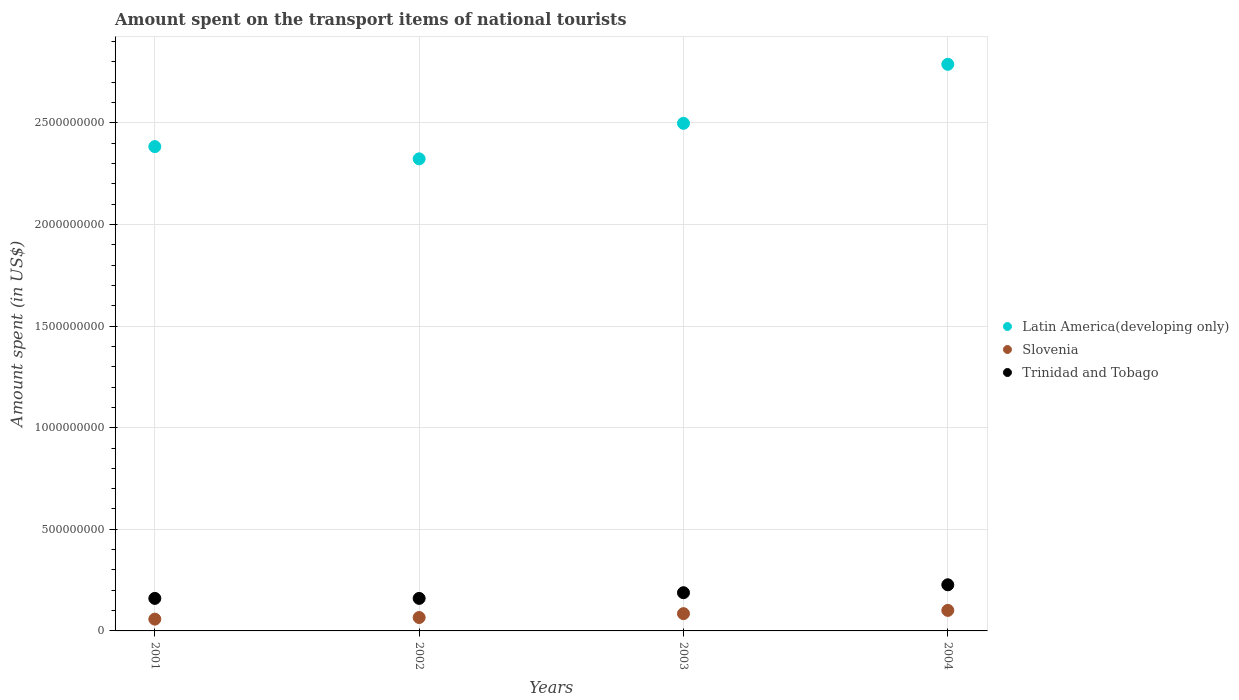Is the number of dotlines equal to the number of legend labels?
Offer a terse response. Yes. What is the amount spent on the transport items of national tourists in Trinidad and Tobago in 2003?
Your answer should be compact. 1.88e+08. Across all years, what is the maximum amount spent on the transport items of national tourists in Latin America(developing only)?
Your response must be concise. 2.79e+09. Across all years, what is the minimum amount spent on the transport items of national tourists in Trinidad and Tobago?
Offer a very short reply. 1.60e+08. In which year was the amount spent on the transport items of national tourists in Trinidad and Tobago minimum?
Provide a short and direct response. 2001. What is the total amount spent on the transport items of national tourists in Trinidad and Tobago in the graph?
Make the answer very short. 7.35e+08. What is the difference between the amount spent on the transport items of national tourists in Slovenia in 2001 and that in 2004?
Give a very brief answer. -4.30e+07. What is the difference between the amount spent on the transport items of national tourists in Slovenia in 2003 and the amount spent on the transport items of national tourists in Trinidad and Tobago in 2001?
Ensure brevity in your answer.  -7.50e+07. What is the average amount spent on the transport items of national tourists in Slovenia per year?
Provide a succinct answer. 7.75e+07. In the year 2001, what is the difference between the amount spent on the transport items of national tourists in Trinidad and Tobago and amount spent on the transport items of national tourists in Slovenia?
Your answer should be very brief. 1.02e+08. In how many years, is the amount spent on the transport items of national tourists in Latin America(developing only) greater than 100000000 US$?
Make the answer very short. 4. What is the ratio of the amount spent on the transport items of national tourists in Latin America(developing only) in 2003 to that in 2004?
Give a very brief answer. 0.9. Is the amount spent on the transport items of national tourists in Trinidad and Tobago in 2002 less than that in 2004?
Ensure brevity in your answer.  Yes. Is the difference between the amount spent on the transport items of national tourists in Trinidad and Tobago in 2002 and 2004 greater than the difference between the amount spent on the transport items of national tourists in Slovenia in 2002 and 2004?
Your answer should be compact. No. What is the difference between the highest and the second highest amount spent on the transport items of national tourists in Latin America(developing only)?
Provide a short and direct response. 2.90e+08. What is the difference between the highest and the lowest amount spent on the transport items of national tourists in Slovenia?
Provide a succinct answer. 4.30e+07. Is it the case that in every year, the sum of the amount spent on the transport items of national tourists in Latin America(developing only) and amount spent on the transport items of national tourists in Trinidad and Tobago  is greater than the amount spent on the transport items of national tourists in Slovenia?
Your response must be concise. Yes. Does the amount spent on the transport items of national tourists in Latin America(developing only) monotonically increase over the years?
Make the answer very short. No. Is the amount spent on the transport items of national tourists in Latin America(developing only) strictly greater than the amount spent on the transport items of national tourists in Slovenia over the years?
Provide a succinct answer. Yes. Is the amount spent on the transport items of national tourists in Trinidad and Tobago strictly less than the amount spent on the transport items of national tourists in Slovenia over the years?
Offer a very short reply. No. What is the difference between two consecutive major ticks on the Y-axis?
Give a very brief answer. 5.00e+08. Does the graph contain grids?
Offer a terse response. Yes. How are the legend labels stacked?
Give a very brief answer. Vertical. What is the title of the graph?
Give a very brief answer. Amount spent on the transport items of national tourists. What is the label or title of the X-axis?
Your response must be concise. Years. What is the label or title of the Y-axis?
Offer a very short reply. Amount spent (in US$). What is the Amount spent (in US$) of Latin America(developing only) in 2001?
Offer a very short reply. 2.38e+09. What is the Amount spent (in US$) of Slovenia in 2001?
Keep it short and to the point. 5.80e+07. What is the Amount spent (in US$) in Trinidad and Tobago in 2001?
Provide a short and direct response. 1.60e+08. What is the Amount spent (in US$) of Latin America(developing only) in 2002?
Give a very brief answer. 2.32e+09. What is the Amount spent (in US$) of Slovenia in 2002?
Provide a short and direct response. 6.60e+07. What is the Amount spent (in US$) in Trinidad and Tobago in 2002?
Provide a succinct answer. 1.60e+08. What is the Amount spent (in US$) in Latin America(developing only) in 2003?
Your response must be concise. 2.50e+09. What is the Amount spent (in US$) of Slovenia in 2003?
Provide a short and direct response. 8.50e+07. What is the Amount spent (in US$) of Trinidad and Tobago in 2003?
Make the answer very short. 1.88e+08. What is the Amount spent (in US$) of Latin America(developing only) in 2004?
Ensure brevity in your answer.  2.79e+09. What is the Amount spent (in US$) in Slovenia in 2004?
Offer a very short reply. 1.01e+08. What is the Amount spent (in US$) of Trinidad and Tobago in 2004?
Provide a succinct answer. 2.27e+08. Across all years, what is the maximum Amount spent (in US$) in Latin America(developing only)?
Give a very brief answer. 2.79e+09. Across all years, what is the maximum Amount spent (in US$) of Slovenia?
Your response must be concise. 1.01e+08. Across all years, what is the maximum Amount spent (in US$) in Trinidad and Tobago?
Keep it short and to the point. 2.27e+08. Across all years, what is the minimum Amount spent (in US$) in Latin America(developing only)?
Offer a terse response. 2.32e+09. Across all years, what is the minimum Amount spent (in US$) in Slovenia?
Provide a succinct answer. 5.80e+07. Across all years, what is the minimum Amount spent (in US$) in Trinidad and Tobago?
Provide a succinct answer. 1.60e+08. What is the total Amount spent (in US$) of Latin America(developing only) in the graph?
Offer a very short reply. 9.99e+09. What is the total Amount spent (in US$) in Slovenia in the graph?
Provide a succinct answer. 3.10e+08. What is the total Amount spent (in US$) in Trinidad and Tobago in the graph?
Your answer should be very brief. 7.35e+08. What is the difference between the Amount spent (in US$) in Latin America(developing only) in 2001 and that in 2002?
Provide a succinct answer. 6.03e+07. What is the difference between the Amount spent (in US$) in Slovenia in 2001 and that in 2002?
Offer a terse response. -8.00e+06. What is the difference between the Amount spent (in US$) of Latin America(developing only) in 2001 and that in 2003?
Provide a short and direct response. -1.14e+08. What is the difference between the Amount spent (in US$) in Slovenia in 2001 and that in 2003?
Your answer should be compact. -2.70e+07. What is the difference between the Amount spent (in US$) in Trinidad and Tobago in 2001 and that in 2003?
Provide a succinct answer. -2.80e+07. What is the difference between the Amount spent (in US$) in Latin America(developing only) in 2001 and that in 2004?
Your answer should be very brief. -4.05e+08. What is the difference between the Amount spent (in US$) in Slovenia in 2001 and that in 2004?
Provide a succinct answer. -4.30e+07. What is the difference between the Amount spent (in US$) of Trinidad and Tobago in 2001 and that in 2004?
Make the answer very short. -6.70e+07. What is the difference between the Amount spent (in US$) in Latin America(developing only) in 2002 and that in 2003?
Provide a succinct answer. -1.75e+08. What is the difference between the Amount spent (in US$) of Slovenia in 2002 and that in 2003?
Make the answer very short. -1.90e+07. What is the difference between the Amount spent (in US$) in Trinidad and Tobago in 2002 and that in 2003?
Provide a succinct answer. -2.80e+07. What is the difference between the Amount spent (in US$) in Latin America(developing only) in 2002 and that in 2004?
Your response must be concise. -4.65e+08. What is the difference between the Amount spent (in US$) of Slovenia in 2002 and that in 2004?
Give a very brief answer. -3.50e+07. What is the difference between the Amount spent (in US$) of Trinidad and Tobago in 2002 and that in 2004?
Provide a succinct answer. -6.70e+07. What is the difference between the Amount spent (in US$) in Latin America(developing only) in 2003 and that in 2004?
Offer a very short reply. -2.90e+08. What is the difference between the Amount spent (in US$) of Slovenia in 2003 and that in 2004?
Your answer should be compact. -1.60e+07. What is the difference between the Amount spent (in US$) in Trinidad and Tobago in 2003 and that in 2004?
Ensure brevity in your answer.  -3.90e+07. What is the difference between the Amount spent (in US$) in Latin America(developing only) in 2001 and the Amount spent (in US$) in Slovenia in 2002?
Ensure brevity in your answer.  2.32e+09. What is the difference between the Amount spent (in US$) of Latin America(developing only) in 2001 and the Amount spent (in US$) of Trinidad and Tobago in 2002?
Provide a succinct answer. 2.22e+09. What is the difference between the Amount spent (in US$) in Slovenia in 2001 and the Amount spent (in US$) in Trinidad and Tobago in 2002?
Give a very brief answer. -1.02e+08. What is the difference between the Amount spent (in US$) of Latin America(developing only) in 2001 and the Amount spent (in US$) of Slovenia in 2003?
Give a very brief answer. 2.30e+09. What is the difference between the Amount spent (in US$) of Latin America(developing only) in 2001 and the Amount spent (in US$) of Trinidad and Tobago in 2003?
Your response must be concise. 2.20e+09. What is the difference between the Amount spent (in US$) in Slovenia in 2001 and the Amount spent (in US$) in Trinidad and Tobago in 2003?
Your answer should be compact. -1.30e+08. What is the difference between the Amount spent (in US$) of Latin America(developing only) in 2001 and the Amount spent (in US$) of Slovenia in 2004?
Your answer should be very brief. 2.28e+09. What is the difference between the Amount spent (in US$) of Latin America(developing only) in 2001 and the Amount spent (in US$) of Trinidad and Tobago in 2004?
Provide a succinct answer. 2.16e+09. What is the difference between the Amount spent (in US$) of Slovenia in 2001 and the Amount spent (in US$) of Trinidad and Tobago in 2004?
Offer a very short reply. -1.69e+08. What is the difference between the Amount spent (in US$) in Latin America(developing only) in 2002 and the Amount spent (in US$) in Slovenia in 2003?
Make the answer very short. 2.24e+09. What is the difference between the Amount spent (in US$) of Latin America(developing only) in 2002 and the Amount spent (in US$) of Trinidad and Tobago in 2003?
Your answer should be compact. 2.13e+09. What is the difference between the Amount spent (in US$) of Slovenia in 2002 and the Amount spent (in US$) of Trinidad and Tobago in 2003?
Your response must be concise. -1.22e+08. What is the difference between the Amount spent (in US$) in Latin America(developing only) in 2002 and the Amount spent (in US$) in Slovenia in 2004?
Give a very brief answer. 2.22e+09. What is the difference between the Amount spent (in US$) of Latin America(developing only) in 2002 and the Amount spent (in US$) of Trinidad and Tobago in 2004?
Offer a terse response. 2.10e+09. What is the difference between the Amount spent (in US$) of Slovenia in 2002 and the Amount spent (in US$) of Trinidad and Tobago in 2004?
Offer a terse response. -1.61e+08. What is the difference between the Amount spent (in US$) of Latin America(developing only) in 2003 and the Amount spent (in US$) of Slovenia in 2004?
Offer a very short reply. 2.40e+09. What is the difference between the Amount spent (in US$) of Latin America(developing only) in 2003 and the Amount spent (in US$) of Trinidad and Tobago in 2004?
Keep it short and to the point. 2.27e+09. What is the difference between the Amount spent (in US$) of Slovenia in 2003 and the Amount spent (in US$) of Trinidad and Tobago in 2004?
Offer a very short reply. -1.42e+08. What is the average Amount spent (in US$) of Latin America(developing only) per year?
Give a very brief answer. 2.50e+09. What is the average Amount spent (in US$) of Slovenia per year?
Make the answer very short. 7.75e+07. What is the average Amount spent (in US$) in Trinidad and Tobago per year?
Provide a short and direct response. 1.84e+08. In the year 2001, what is the difference between the Amount spent (in US$) in Latin America(developing only) and Amount spent (in US$) in Slovenia?
Make the answer very short. 2.33e+09. In the year 2001, what is the difference between the Amount spent (in US$) of Latin America(developing only) and Amount spent (in US$) of Trinidad and Tobago?
Your answer should be very brief. 2.22e+09. In the year 2001, what is the difference between the Amount spent (in US$) in Slovenia and Amount spent (in US$) in Trinidad and Tobago?
Ensure brevity in your answer.  -1.02e+08. In the year 2002, what is the difference between the Amount spent (in US$) in Latin America(developing only) and Amount spent (in US$) in Slovenia?
Provide a short and direct response. 2.26e+09. In the year 2002, what is the difference between the Amount spent (in US$) in Latin America(developing only) and Amount spent (in US$) in Trinidad and Tobago?
Your answer should be compact. 2.16e+09. In the year 2002, what is the difference between the Amount spent (in US$) in Slovenia and Amount spent (in US$) in Trinidad and Tobago?
Provide a short and direct response. -9.40e+07. In the year 2003, what is the difference between the Amount spent (in US$) in Latin America(developing only) and Amount spent (in US$) in Slovenia?
Give a very brief answer. 2.41e+09. In the year 2003, what is the difference between the Amount spent (in US$) in Latin America(developing only) and Amount spent (in US$) in Trinidad and Tobago?
Your answer should be very brief. 2.31e+09. In the year 2003, what is the difference between the Amount spent (in US$) in Slovenia and Amount spent (in US$) in Trinidad and Tobago?
Keep it short and to the point. -1.03e+08. In the year 2004, what is the difference between the Amount spent (in US$) in Latin America(developing only) and Amount spent (in US$) in Slovenia?
Offer a terse response. 2.69e+09. In the year 2004, what is the difference between the Amount spent (in US$) in Latin America(developing only) and Amount spent (in US$) in Trinidad and Tobago?
Provide a short and direct response. 2.56e+09. In the year 2004, what is the difference between the Amount spent (in US$) of Slovenia and Amount spent (in US$) of Trinidad and Tobago?
Offer a very short reply. -1.26e+08. What is the ratio of the Amount spent (in US$) in Slovenia in 2001 to that in 2002?
Your answer should be very brief. 0.88. What is the ratio of the Amount spent (in US$) of Trinidad and Tobago in 2001 to that in 2002?
Offer a very short reply. 1. What is the ratio of the Amount spent (in US$) of Latin America(developing only) in 2001 to that in 2003?
Give a very brief answer. 0.95. What is the ratio of the Amount spent (in US$) in Slovenia in 2001 to that in 2003?
Make the answer very short. 0.68. What is the ratio of the Amount spent (in US$) in Trinidad and Tobago in 2001 to that in 2003?
Your answer should be very brief. 0.85. What is the ratio of the Amount spent (in US$) in Latin America(developing only) in 2001 to that in 2004?
Make the answer very short. 0.85. What is the ratio of the Amount spent (in US$) of Slovenia in 2001 to that in 2004?
Give a very brief answer. 0.57. What is the ratio of the Amount spent (in US$) in Trinidad and Tobago in 2001 to that in 2004?
Give a very brief answer. 0.7. What is the ratio of the Amount spent (in US$) of Latin America(developing only) in 2002 to that in 2003?
Provide a short and direct response. 0.93. What is the ratio of the Amount spent (in US$) in Slovenia in 2002 to that in 2003?
Provide a short and direct response. 0.78. What is the ratio of the Amount spent (in US$) of Trinidad and Tobago in 2002 to that in 2003?
Give a very brief answer. 0.85. What is the ratio of the Amount spent (in US$) of Latin America(developing only) in 2002 to that in 2004?
Your response must be concise. 0.83. What is the ratio of the Amount spent (in US$) in Slovenia in 2002 to that in 2004?
Offer a terse response. 0.65. What is the ratio of the Amount spent (in US$) in Trinidad and Tobago in 2002 to that in 2004?
Make the answer very short. 0.7. What is the ratio of the Amount spent (in US$) of Latin America(developing only) in 2003 to that in 2004?
Provide a succinct answer. 0.9. What is the ratio of the Amount spent (in US$) of Slovenia in 2003 to that in 2004?
Provide a succinct answer. 0.84. What is the ratio of the Amount spent (in US$) of Trinidad and Tobago in 2003 to that in 2004?
Keep it short and to the point. 0.83. What is the difference between the highest and the second highest Amount spent (in US$) of Latin America(developing only)?
Your answer should be very brief. 2.90e+08. What is the difference between the highest and the second highest Amount spent (in US$) in Slovenia?
Give a very brief answer. 1.60e+07. What is the difference between the highest and the second highest Amount spent (in US$) of Trinidad and Tobago?
Provide a succinct answer. 3.90e+07. What is the difference between the highest and the lowest Amount spent (in US$) in Latin America(developing only)?
Offer a very short reply. 4.65e+08. What is the difference between the highest and the lowest Amount spent (in US$) of Slovenia?
Give a very brief answer. 4.30e+07. What is the difference between the highest and the lowest Amount spent (in US$) in Trinidad and Tobago?
Ensure brevity in your answer.  6.70e+07. 